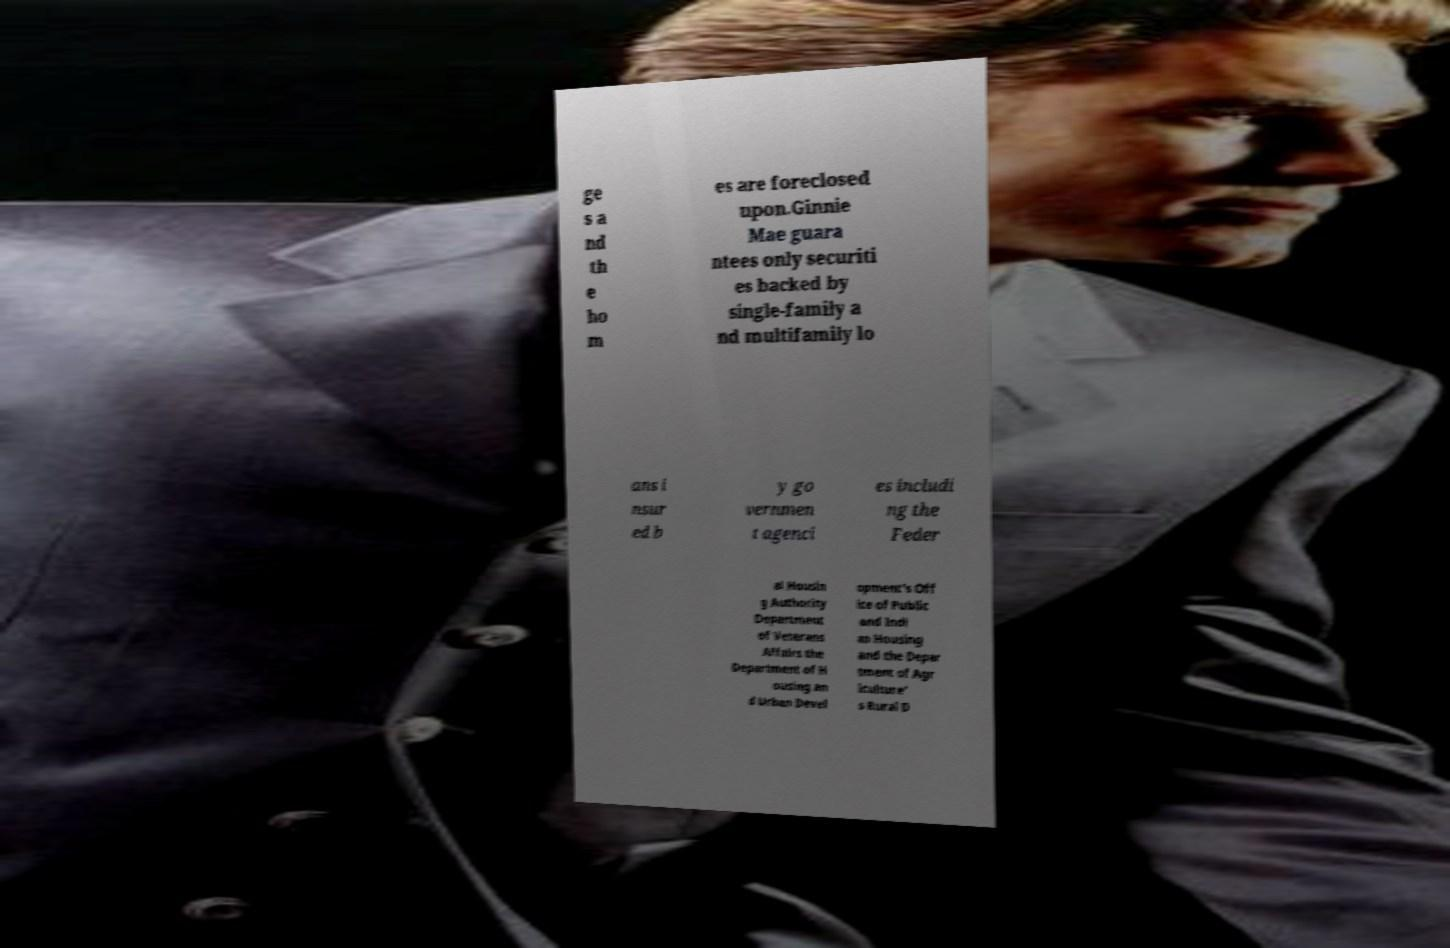Please identify and transcribe the text found in this image. ge s a nd th e ho m es are foreclosed upon.Ginnie Mae guara ntees only securiti es backed by single-family a nd multifamily lo ans i nsur ed b y go vernmen t agenci es includi ng the Feder al Housin g Authority Department of Veterans Affairs the Department of H ousing an d Urban Devel opment’s Off ice of Public and Indi an Housing and the Depar tment of Agr iculture’ s Rural D 